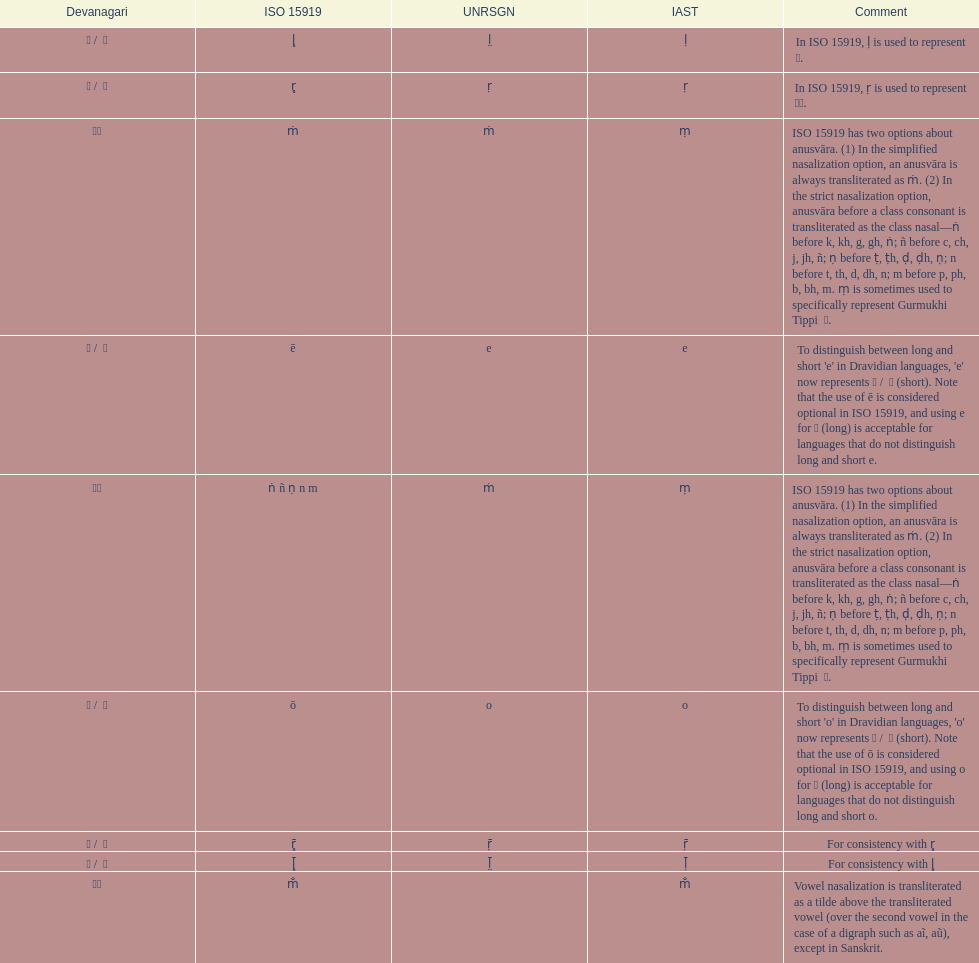What iast is listed before the o? E. 